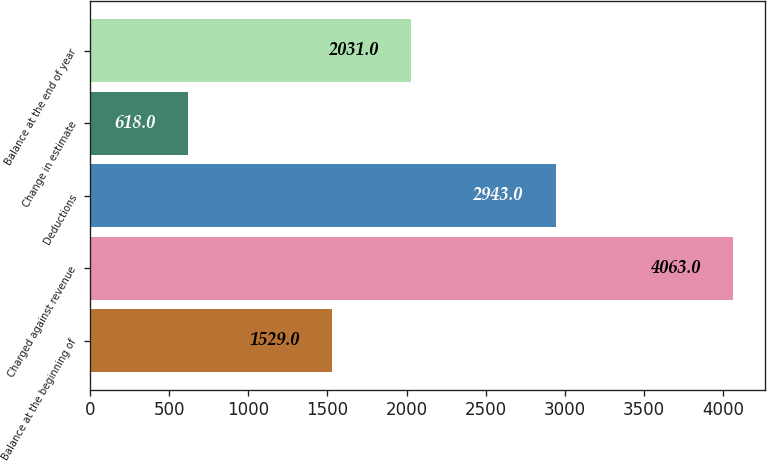Convert chart. <chart><loc_0><loc_0><loc_500><loc_500><bar_chart><fcel>Balance at the beginning of<fcel>Charged against revenue<fcel>Deductions<fcel>Change in estimate<fcel>Balance at the end of year<nl><fcel>1529<fcel>4063<fcel>2943<fcel>618<fcel>2031<nl></chart> 